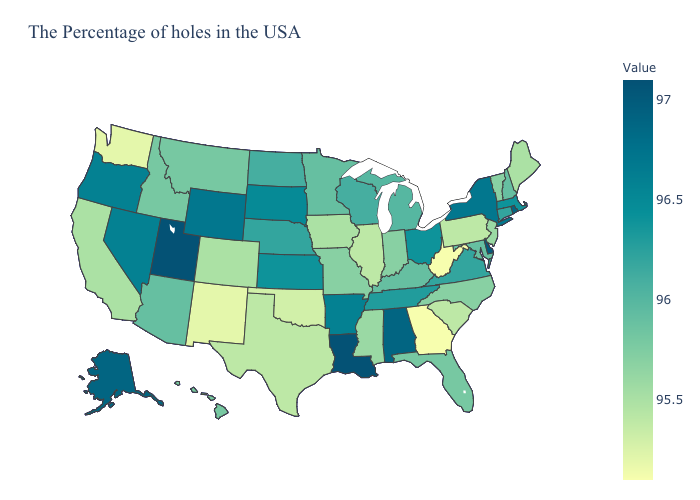Does the map have missing data?
Short answer required. No. Does Florida have the lowest value in the USA?
Be succinct. No. Among the states that border Missouri , which have the lowest value?
Write a very short answer. Oklahoma. Does Utah have the highest value in the West?
Quick response, please. Yes. 